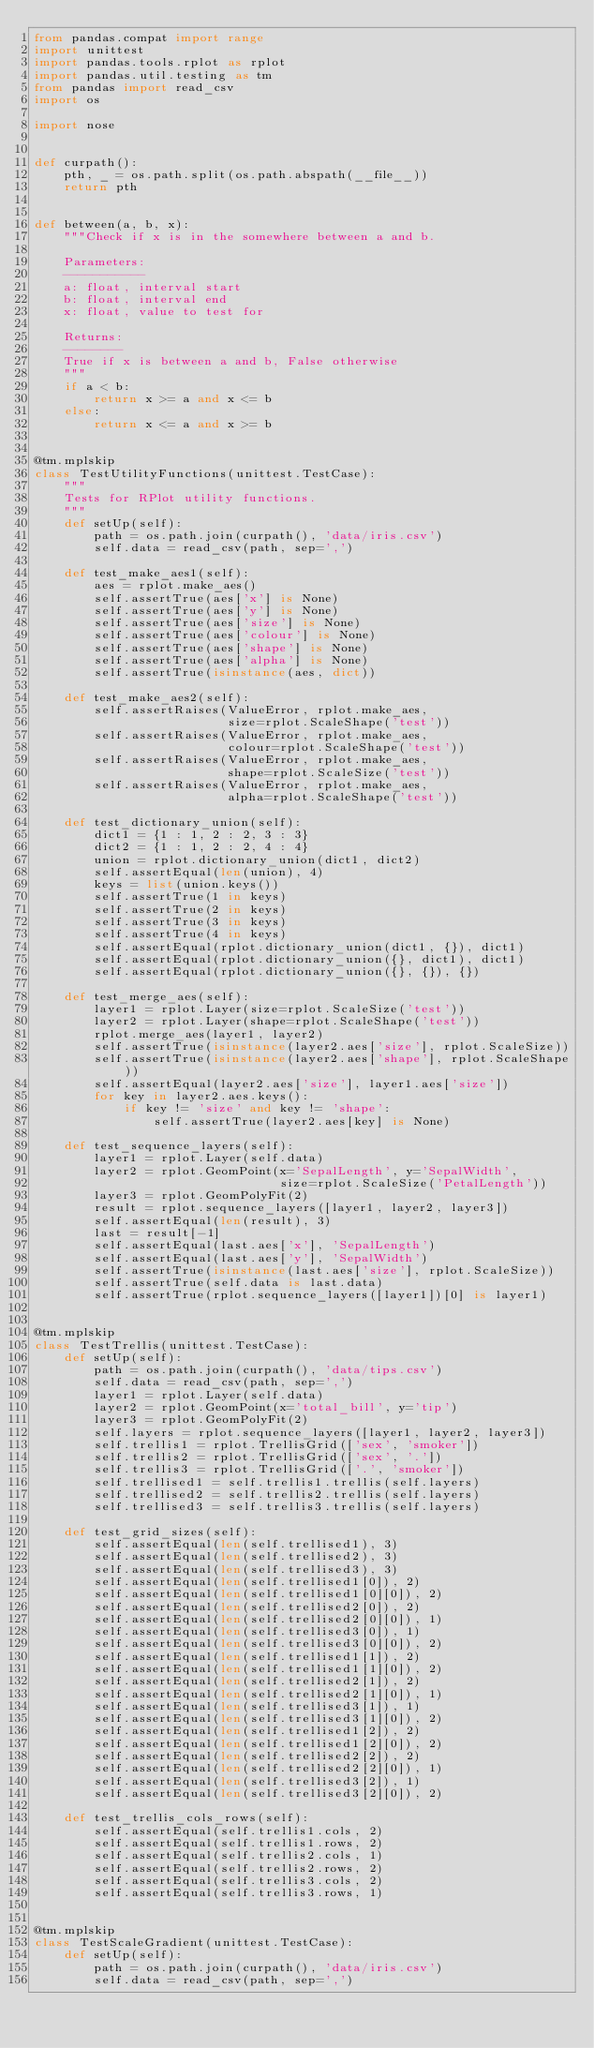<code> <loc_0><loc_0><loc_500><loc_500><_Python_>from pandas.compat import range
import unittest
import pandas.tools.rplot as rplot
import pandas.util.testing as tm
from pandas import read_csv
import os

import nose


def curpath():
    pth, _ = os.path.split(os.path.abspath(__file__))
    return pth


def between(a, b, x):
    """Check if x is in the somewhere between a and b.

    Parameters:
    -----------
    a: float, interval start
    b: float, interval end
    x: float, value to test for

    Returns:
    --------
    True if x is between a and b, False otherwise
    """
    if a < b:
        return x >= a and x <= b
    else:
        return x <= a and x >= b


@tm.mplskip
class TestUtilityFunctions(unittest.TestCase):
    """
    Tests for RPlot utility functions.
    """
    def setUp(self):
        path = os.path.join(curpath(), 'data/iris.csv')
        self.data = read_csv(path, sep=',')

    def test_make_aes1(self):
        aes = rplot.make_aes()
        self.assertTrue(aes['x'] is None)
        self.assertTrue(aes['y'] is None)
        self.assertTrue(aes['size'] is None)
        self.assertTrue(aes['colour'] is None)
        self.assertTrue(aes['shape'] is None)
        self.assertTrue(aes['alpha'] is None)
        self.assertTrue(isinstance(aes, dict))

    def test_make_aes2(self):
        self.assertRaises(ValueError, rplot.make_aes,
                          size=rplot.ScaleShape('test'))
        self.assertRaises(ValueError, rplot.make_aes,
                          colour=rplot.ScaleShape('test'))
        self.assertRaises(ValueError, rplot.make_aes,
                          shape=rplot.ScaleSize('test'))
        self.assertRaises(ValueError, rplot.make_aes,
                          alpha=rplot.ScaleShape('test'))

    def test_dictionary_union(self):
        dict1 = {1 : 1, 2 : 2, 3 : 3}
        dict2 = {1 : 1, 2 : 2, 4 : 4}
        union = rplot.dictionary_union(dict1, dict2)
        self.assertEqual(len(union), 4)
        keys = list(union.keys())
        self.assertTrue(1 in keys)
        self.assertTrue(2 in keys)
        self.assertTrue(3 in keys)
        self.assertTrue(4 in keys)
        self.assertEqual(rplot.dictionary_union(dict1, {}), dict1)
        self.assertEqual(rplot.dictionary_union({}, dict1), dict1)
        self.assertEqual(rplot.dictionary_union({}, {}), {})

    def test_merge_aes(self):
        layer1 = rplot.Layer(size=rplot.ScaleSize('test'))
        layer2 = rplot.Layer(shape=rplot.ScaleShape('test'))
        rplot.merge_aes(layer1, layer2)
        self.assertTrue(isinstance(layer2.aes['size'], rplot.ScaleSize))
        self.assertTrue(isinstance(layer2.aes['shape'], rplot.ScaleShape))
        self.assertEqual(layer2.aes['size'], layer1.aes['size'])
        for key in layer2.aes.keys():
            if key != 'size' and key != 'shape':
                self.assertTrue(layer2.aes[key] is None)

    def test_sequence_layers(self):
        layer1 = rplot.Layer(self.data)
        layer2 = rplot.GeomPoint(x='SepalLength', y='SepalWidth',
                                 size=rplot.ScaleSize('PetalLength'))
        layer3 = rplot.GeomPolyFit(2)
        result = rplot.sequence_layers([layer1, layer2, layer3])
        self.assertEqual(len(result), 3)
        last = result[-1]
        self.assertEqual(last.aes['x'], 'SepalLength')
        self.assertEqual(last.aes['y'], 'SepalWidth')
        self.assertTrue(isinstance(last.aes['size'], rplot.ScaleSize))
        self.assertTrue(self.data is last.data)
        self.assertTrue(rplot.sequence_layers([layer1])[0] is layer1)


@tm.mplskip
class TestTrellis(unittest.TestCase):
    def setUp(self):
        path = os.path.join(curpath(), 'data/tips.csv')
        self.data = read_csv(path, sep=',')
        layer1 = rplot.Layer(self.data)
        layer2 = rplot.GeomPoint(x='total_bill', y='tip')
        layer3 = rplot.GeomPolyFit(2)
        self.layers = rplot.sequence_layers([layer1, layer2, layer3])
        self.trellis1 = rplot.TrellisGrid(['sex', 'smoker'])
        self.trellis2 = rplot.TrellisGrid(['sex', '.'])
        self.trellis3 = rplot.TrellisGrid(['.', 'smoker'])
        self.trellised1 = self.trellis1.trellis(self.layers)
        self.trellised2 = self.trellis2.trellis(self.layers)
        self.trellised3 = self.trellis3.trellis(self.layers)

    def test_grid_sizes(self):
        self.assertEqual(len(self.trellised1), 3)
        self.assertEqual(len(self.trellised2), 3)
        self.assertEqual(len(self.trellised3), 3)
        self.assertEqual(len(self.trellised1[0]), 2)
        self.assertEqual(len(self.trellised1[0][0]), 2)
        self.assertEqual(len(self.trellised2[0]), 2)
        self.assertEqual(len(self.trellised2[0][0]), 1)
        self.assertEqual(len(self.trellised3[0]), 1)
        self.assertEqual(len(self.trellised3[0][0]), 2)
        self.assertEqual(len(self.trellised1[1]), 2)
        self.assertEqual(len(self.trellised1[1][0]), 2)
        self.assertEqual(len(self.trellised2[1]), 2)
        self.assertEqual(len(self.trellised2[1][0]), 1)
        self.assertEqual(len(self.trellised3[1]), 1)
        self.assertEqual(len(self.trellised3[1][0]), 2)
        self.assertEqual(len(self.trellised1[2]), 2)
        self.assertEqual(len(self.trellised1[2][0]), 2)
        self.assertEqual(len(self.trellised2[2]), 2)
        self.assertEqual(len(self.trellised2[2][0]), 1)
        self.assertEqual(len(self.trellised3[2]), 1)
        self.assertEqual(len(self.trellised3[2][0]), 2)

    def test_trellis_cols_rows(self):
        self.assertEqual(self.trellis1.cols, 2)
        self.assertEqual(self.trellis1.rows, 2)
        self.assertEqual(self.trellis2.cols, 1)
        self.assertEqual(self.trellis2.rows, 2)
        self.assertEqual(self.trellis3.cols, 2)
        self.assertEqual(self.trellis3.rows, 1)


@tm.mplskip
class TestScaleGradient(unittest.TestCase):
    def setUp(self):
        path = os.path.join(curpath(), 'data/iris.csv')
        self.data = read_csv(path, sep=',')</code> 